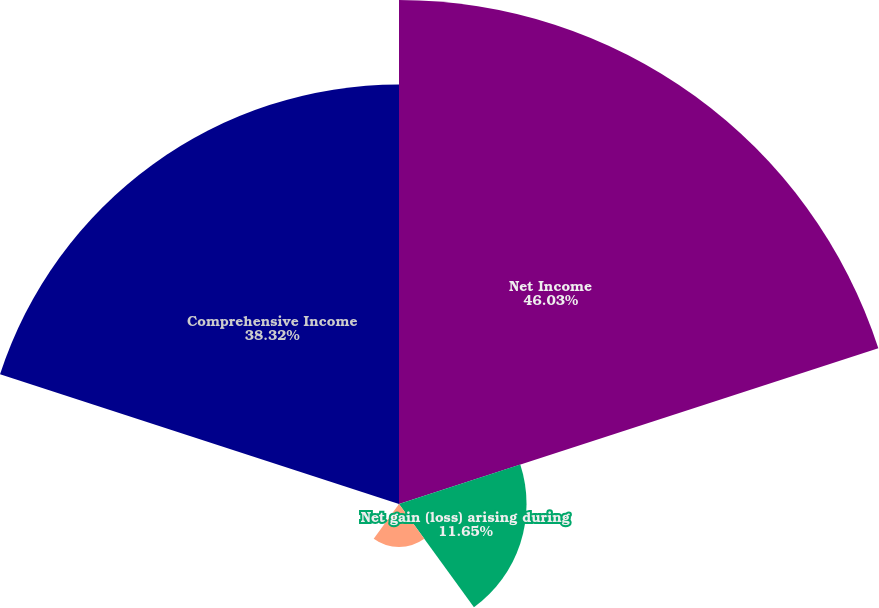<chart> <loc_0><loc_0><loc_500><loc_500><pie_chart><fcel>Net Income<fcel>Net gain (loss) arising during<fcel>Amortization of net actuarial<fcel>Amortization of prior service<fcel>Comprehensive Income<nl><fcel>46.04%<fcel>11.65%<fcel>3.93%<fcel>0.07%<fcel>38.32%<nl></chart> 